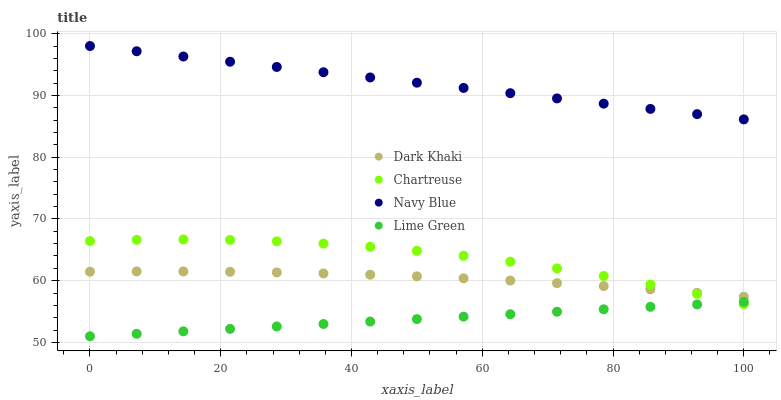Does Lime Green have the minimum area under the curve?
Answer yes or no. Yes. Does Navy Blue have the maximum area under the curve?
Answer yes or no. Yes. Does Chartreuse have the minimum area under the curve?
Answer yes or no. No. Does Chartreuse have the maximum area under the curve?
Answer yes or no. No. Is Navy Blue the smoothest?
Answer yes or no. Yes. Is Chartreuse the roughest?
Answer yes or no. Yes. Is Chartreuse the smoothest?
Answer yes or no. No. Is Navy Blue the roughest?
Answer yes or no. No. Does Lime Green have the lowest value?
Answer yes or no. Yes. Does Chartreuse have the lowest value?
Answer yes or no. No. Does Navy Blue have the highest value?
Answer yes or no. Yes. Does Chartreuse have the highest value?
Answer yes or no. No. Is Lime Green less than Navy Blue?
Answer yes or no. Yes. Is Navy Blue greater than Chartreuse?
Answer yes or no. Yes. Does Lime Green intersect Chartreuse?
Answer yes or no. Yes. Is Lime Green less than Chartreuse?
Answer yes or no. No. Is Lime Green greater than Chartreuse?
Answer yes or no. No. Does Lime Green intersect Navy Blue?
Answer yes or no. No. 